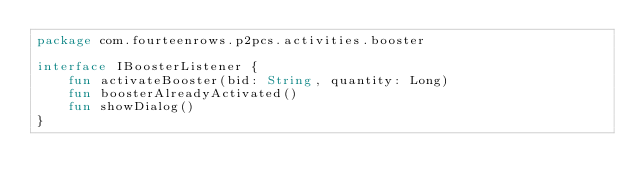<code> <loc_0><loc_0><loc_500><loc_500><_Kotlin_>package com.fourteenrows.p2pcs.activities.booster

interface IBoosterListener {
    fun activateBooster(bid: String, quantity: Long)
    fun boosterAlreadyActivated()
    fun showDialog()
}</code> 